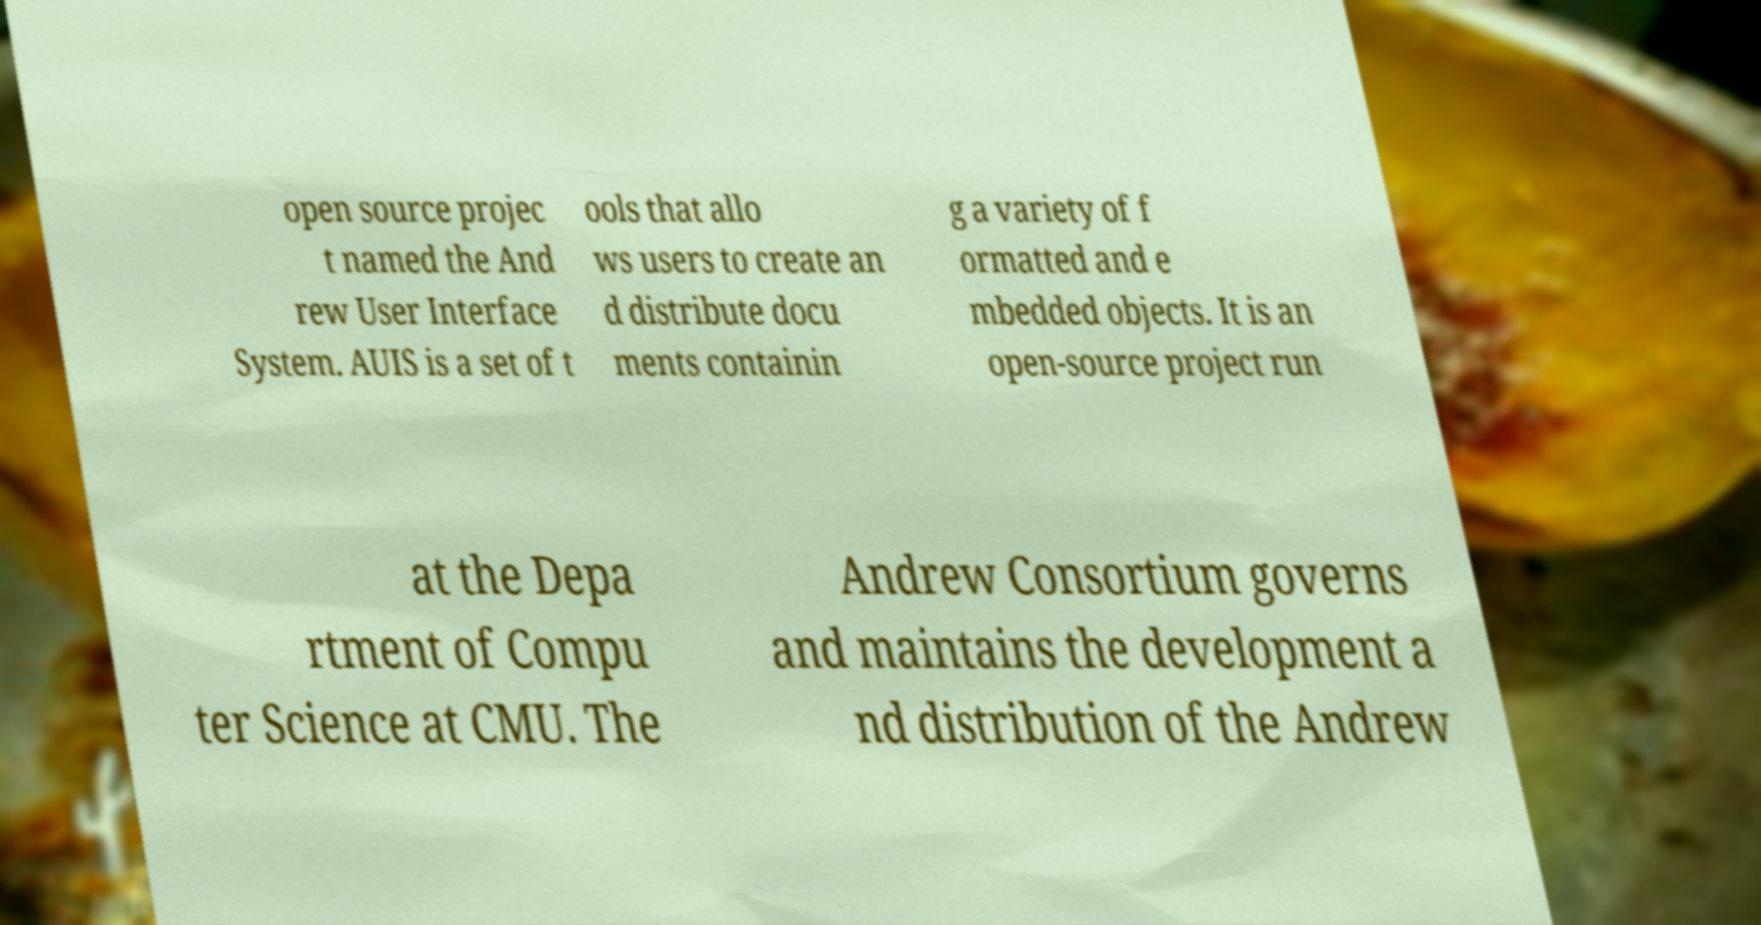What messages or text are displayed in this image? I need them in a readable, typed format. open source projec t named the And rew User Interface System. AUIS is a set of t ools that allo ws users to create an d distribute docu ments containin g a variety of f ormatted and e mbedded objects. It is an open-source project run at the Depa rtment of Compu ter Science at CMU. The Andrew Consortium governs and maintains the development a nd distribution of the Andrew 